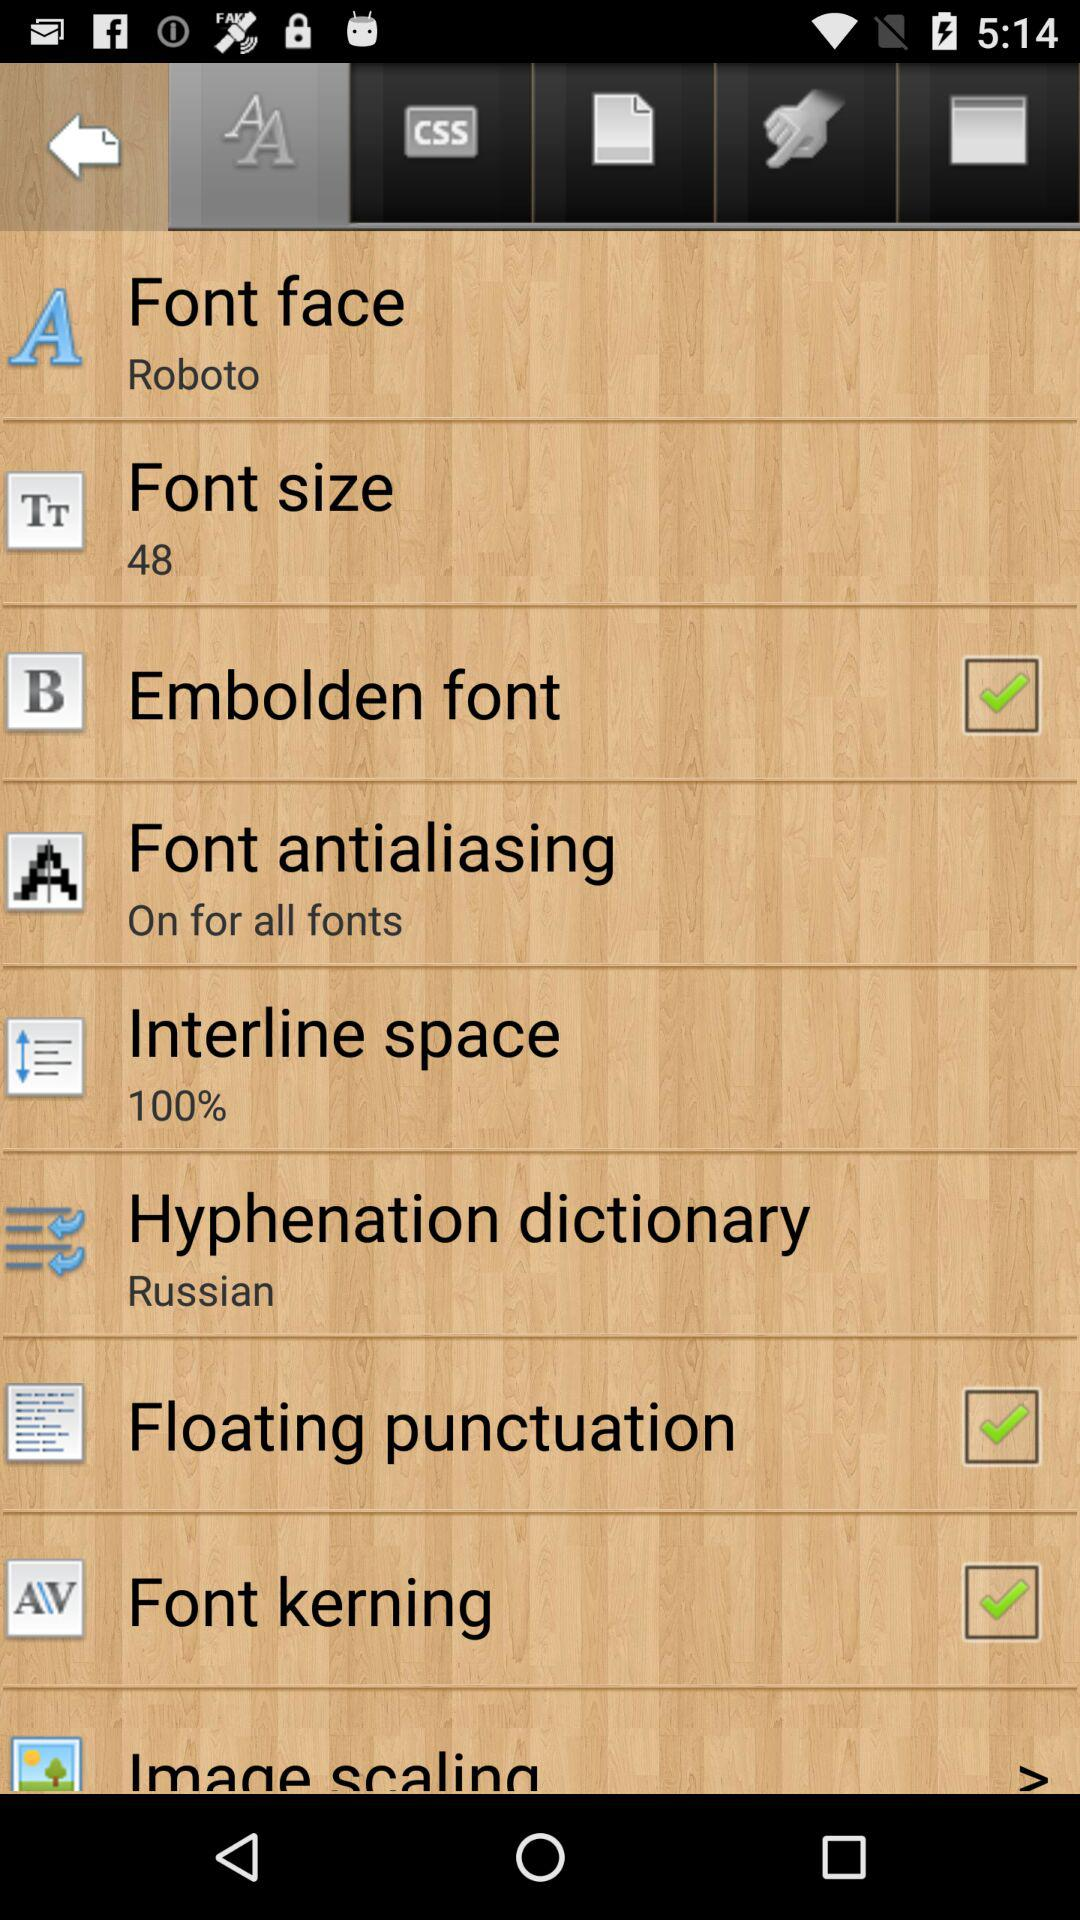What font size is selected? The selected font size is 48. 